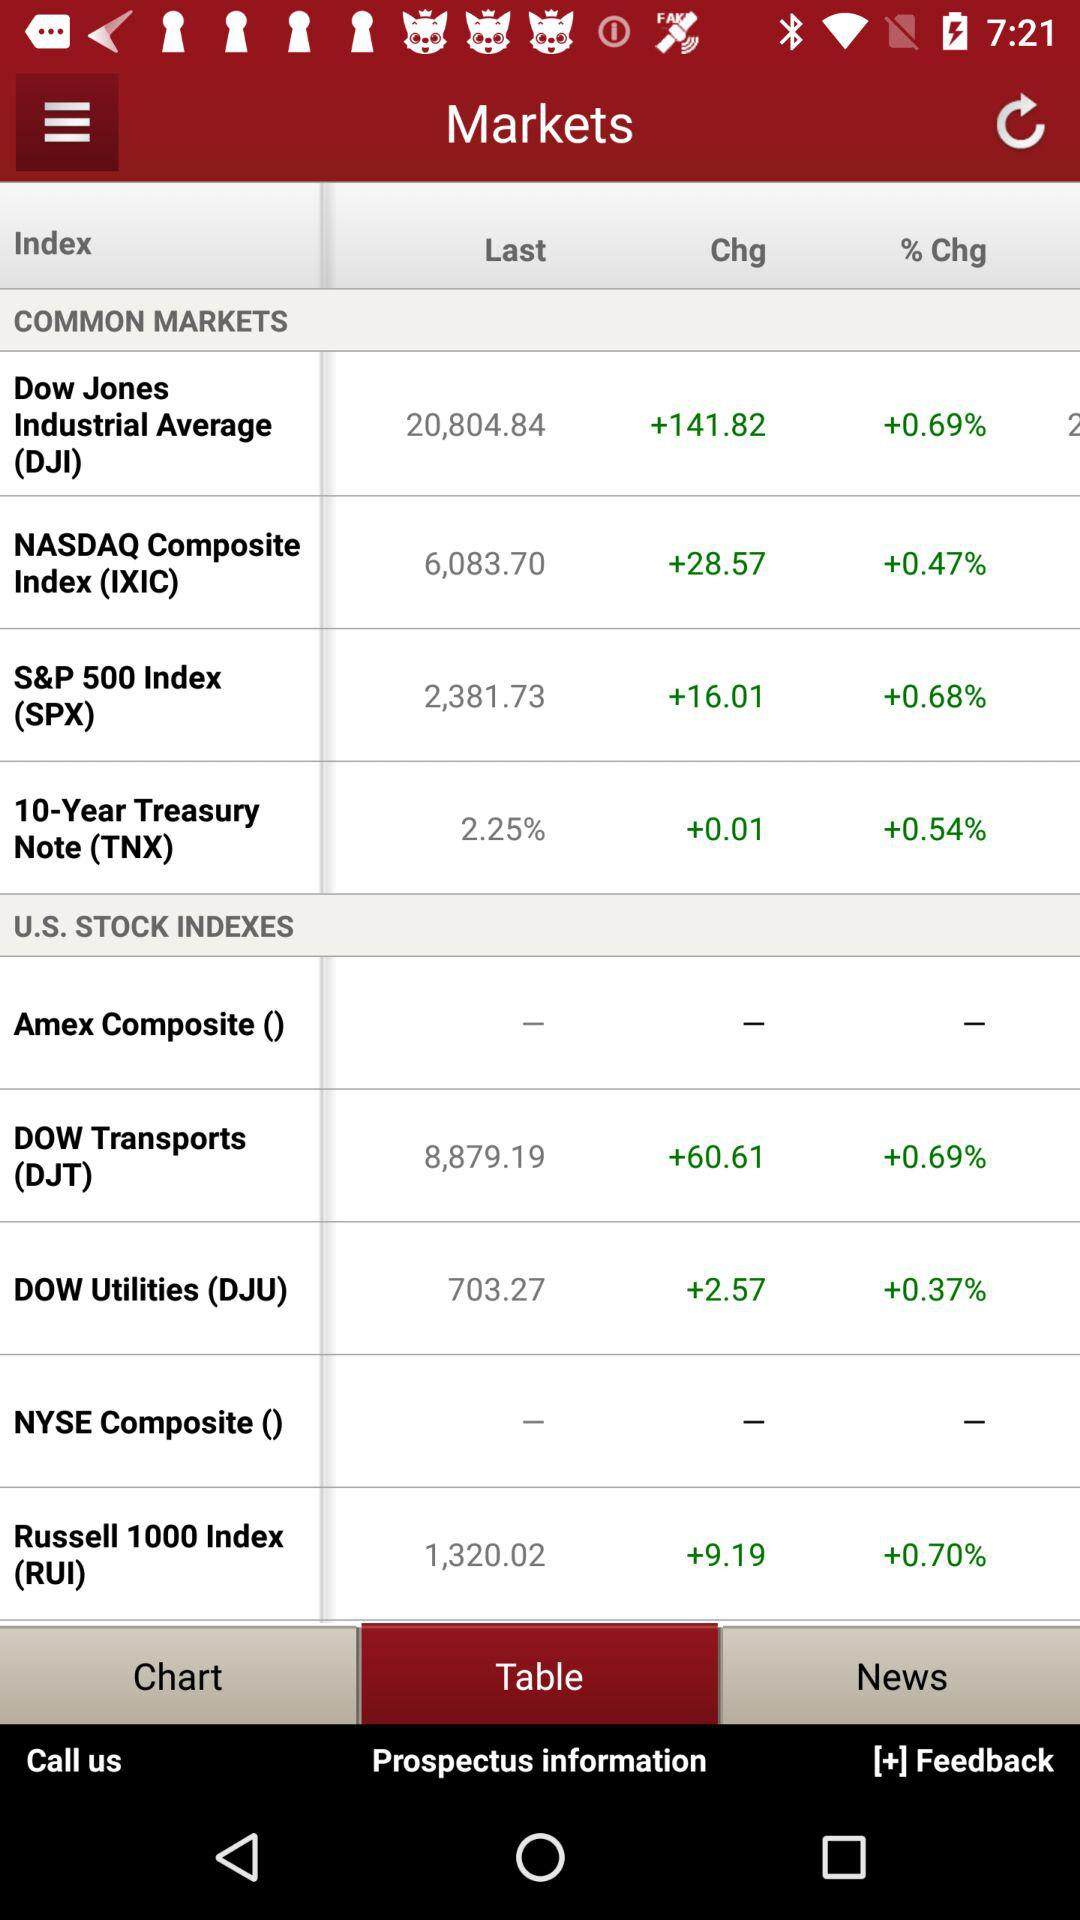Which tab is selected? The selected tab is "Table". 